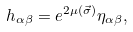Convert formula to latex. <formula><loc_0><loc_0><loc_500><loc_500>h _ { \alpha \beta } = e ^ { 2 \mu ( \vec { \sigma } ) } \eta _ { \alpha \beta } ,</formula> 